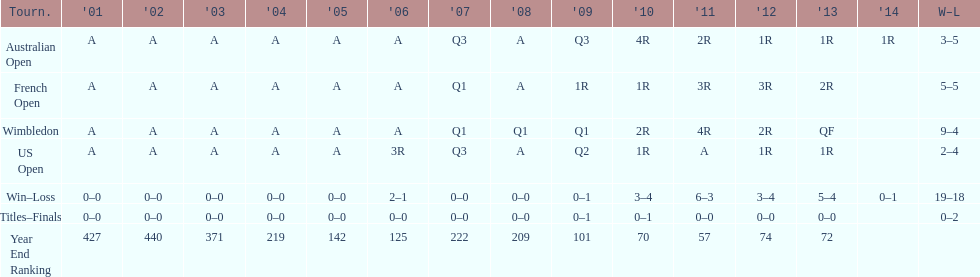How many tournaments had 5 total losses? 2. 